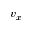<formula> <loc_0><loc_0><loc_500><loc_500>v _ { x }</formula> 